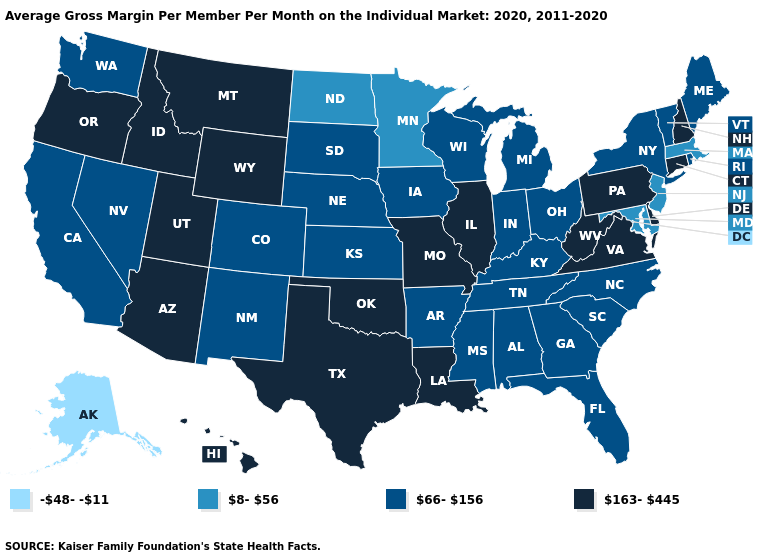Does Vermont have the lowest value in the USA?
Concise answer only. No. Among the states that border Montana , which have the highest value?
Answer briefly. Idaho, Wyoming. Name the states that have a value in the range 163-445?
Concise answer only. Arizona, Connecticut, Delaware, Hawaii, Idaho, Illinois, Louisiana, Missouri, Montana, New Hampshire, Oklahoma, Oregon, Pennsylvania, Texas, Utah, Virginia, West Virginia, Wyoming. Does the map have missing data?
Give a very brief answer. No. Does Pennsylvania have the highest value in the Northeast?
Be succinct. Yes. Among the states that border New York , which have the highest value?
Be succinct. Connecticut, Pennsylvania. What is the lowest value in the South?
Keep it brief. 8-56. What is the highest value in states that border Wisconsin?
Short answer required. 163-445. What is the highest value in states that border Michigan?
Give a very brief answer. 66-156. Name the states that have a value in the range 66-156?
Quick response, please. Alabama, Arkansas, California, Colorado, Florida, Georgia, Indiana, Iowa, Kansas, Kentucky, Maine, Michigan, Mississippi, Nebraska, Nevada, New Mexico, New York, North Carolina, Ohio, Rhode Island, South Carolina, South Dakota, Tennessee, Vermont, Washington, Wisconsin. Does the map have missing data?
Short answer required. No. What is the value of West Virginia?
Keep it brief. 163-445. Name the states that have a value in the range 66-156?
Be succinct. Alabama, Arkansas, California, Colorado, Florida, Georgia, Indiana, Iowa, Kansas, Kentucky, Maine, Michigan, Mississippi, Nebraska, Nevada, New Mexico, New York, North Carolina, Ohio, Rhode Island, South Carolina, South Dakota, Tennessee, Vermont, Washington, Wisconsin. Among the states that border Delaware , does Pennsylvania have the lowest value?
Keep it brief. No. Does Alaska have the lowest value in the USA?
Keep it brief. Yes. 